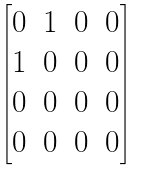Convert formula to latex. <formula><loc_0><loc_0><loc_500><loc_500>\begin{bmatrix} 0 & 1 & 0 & 0 \\ 1 & 0 & 0 & 0 \\ 0 & 0 & 0 & 0 \\ 0 & 0 & 0 & 0 \end{bmatrix}</formula> 